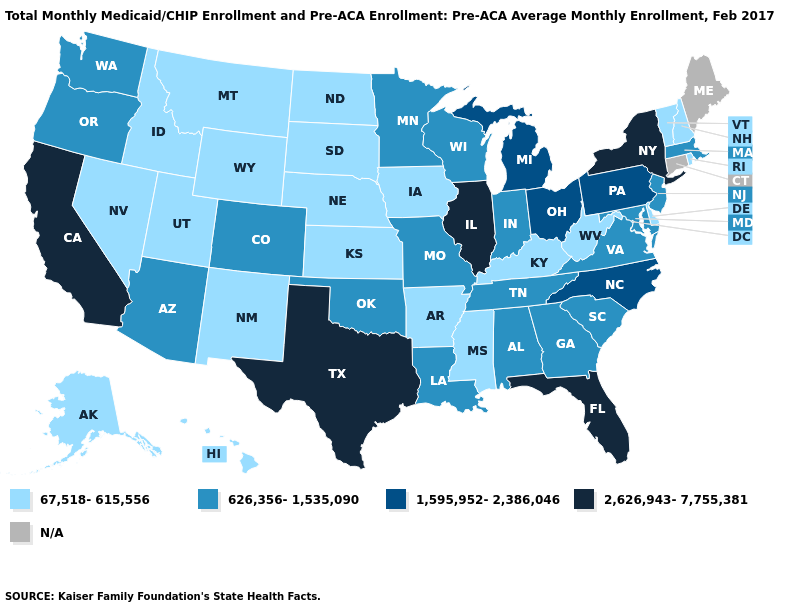Does the first symbol in the legend represent the smallest category?
Give a very brief answer. Yes. Does Texas have the highest value in the USA?
Answer briefly. Yes. What is the highest value in states that border Indiana?
Answer briefly. 2,626,943-7,755,381. Which states have the highest value in the USA?
Concise answer only. California, Florida, Illinois, New York, Texas. Which states have the lowest value in the USA?
Answer briefly. Alaska, Arkansas, Delaware, Hawaii, Idaho, Iowa, Kansas, Kentucky, Mississippi, Montana, Nebraska, Nevada, New Hampshire, New Mexico, North Dakota, Rhode Island, South Dakota, Utah, Vermont, West Virginia, Wyoming. Among the states that border Minnesota , does Wisconsin have the lowest value?
Be succinct. No. What is the lowest value in the South?
Short answer required. 67,518-615,556. Name the states that have a value in the range 1,595,952-2,386,046?
Be succinct. Michigan, North Carolina, Ohio, Pennsylvania. What is the highest value in the Northeast ?
Write a very short answer. 2,626,943-7,755,381. What is the value of Oregon?
Keep it brief. 626,356-1,535,090. Does Alabama have the highest value in the USA?
Short answer required. No. Name the states that have a value in the range 2,626,943-7,755,381?
Short answer required. California, Florida, Illinois, New York, Texas. Among the states that border Illinois , which have the highest value?
Write a very short answer. Indiana, Missouri, Wisconsin. Name the states that have a value in the range 67,518-615,556?
Keep it brief. Alaska, Arkansas, Delaware, Hawaii, Idaho, Iowa, Kansas, Kentucky, Mississippi, Montana, Nebraska, Nevada, New Hampshire, New Mexico, North Dakota, Rhode Island, South Dakota, Utah, Vermont, West Virginia, Wyoming. 